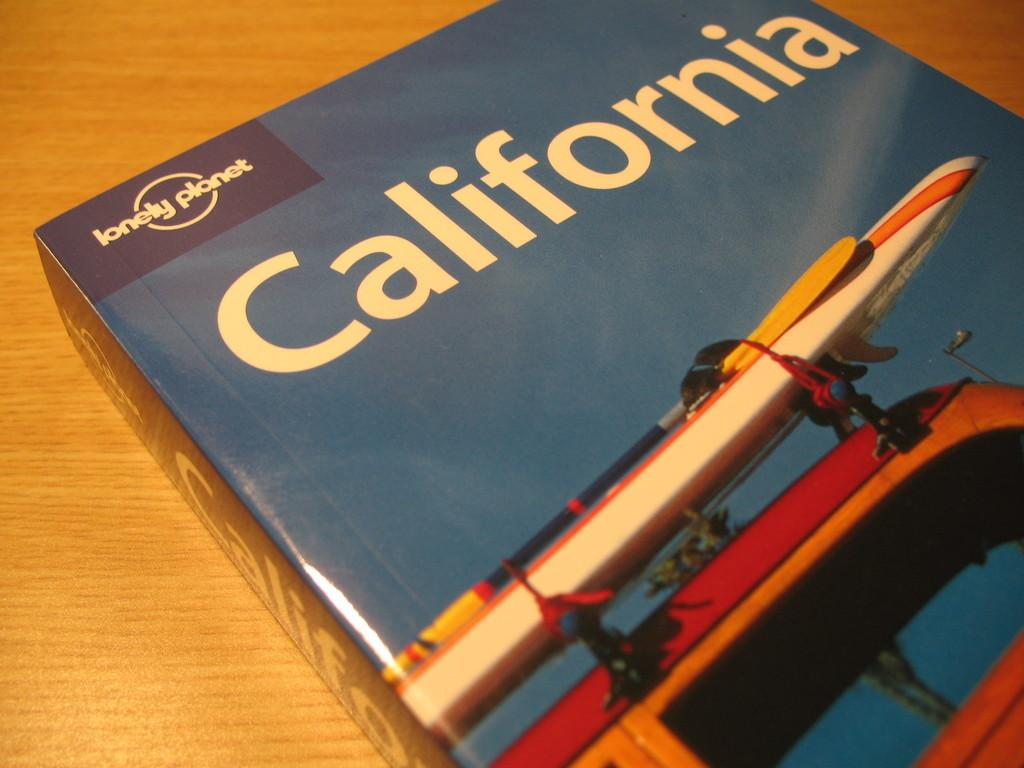<image>
Create a compact narrative representing the image presented. A thick book with a car and a surfboard on it titled California. 